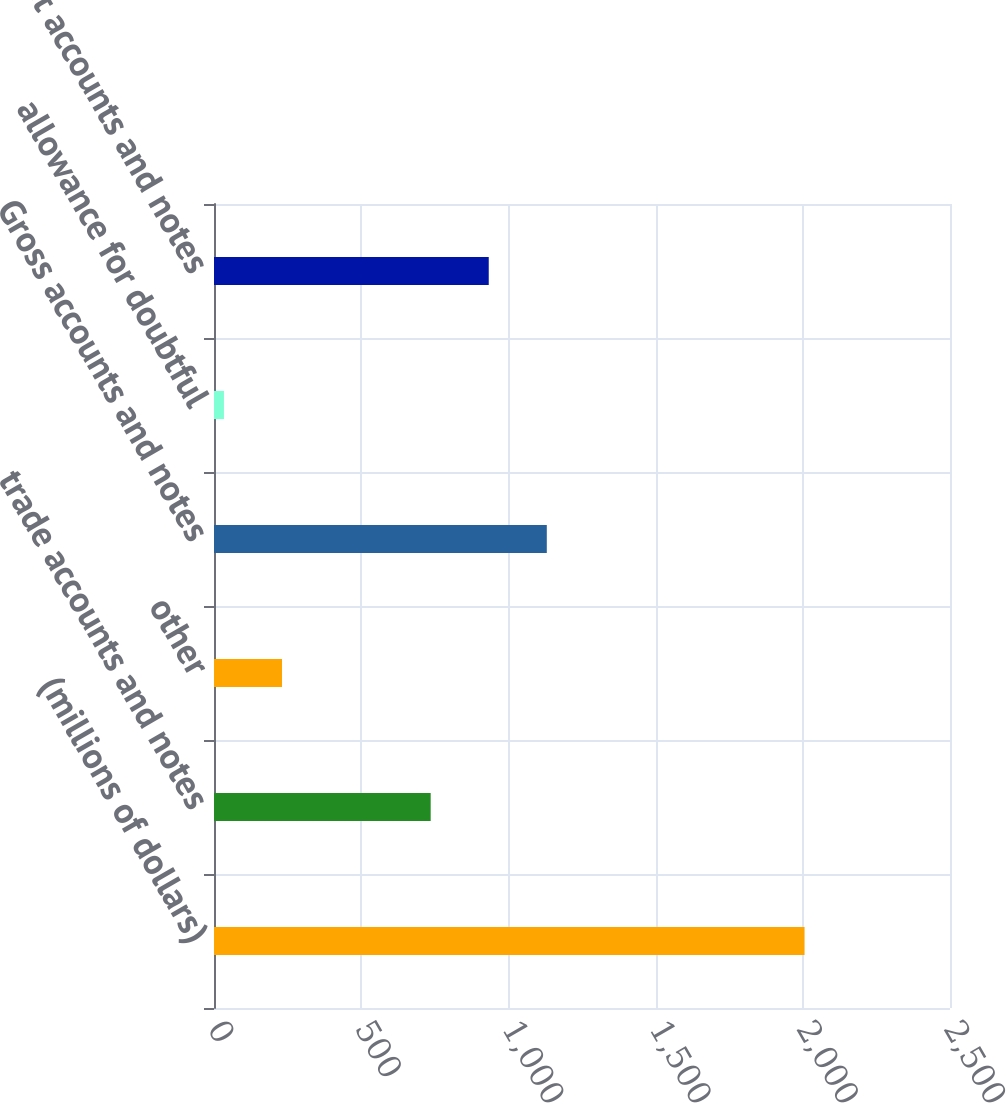Convert chart to OTSL. <chart><loc_0><loc_0><loc_500><loc_500><bar_chart><fcel>(millions of dollars)<fcel>trade accounts and notes<fcel>other<fcel>Gross accounts and notes<fcel>allowance for doubtful<fcel>net accounts and notes<nl><fcel>2006<fcel>736<fcel>231.02<fcel>1130.44<fcel>33.8<fcel>933.22<nl></chart> 